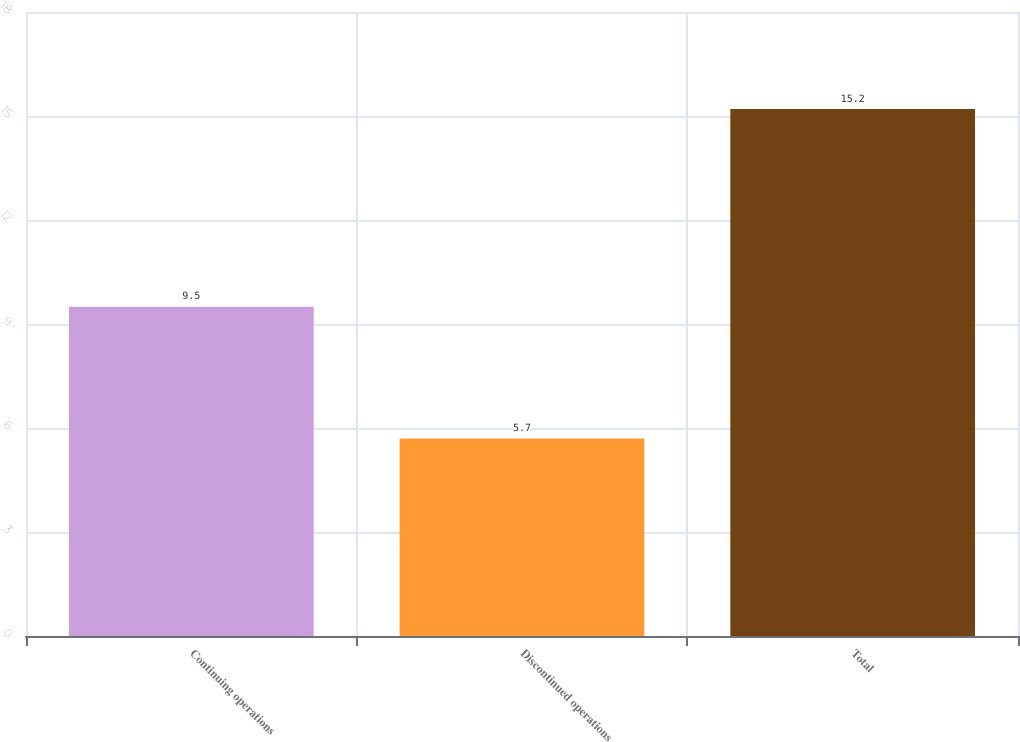Convert chart to OTSL. <chart><loc_0><loc_0><loc_500><loc_500><bar_chart><fcel>Continuing operations<fcel>Discontinued operations<fcel>Total<nl><fcel>9.5<fcel>5.7<fcel>15.2<nl></chart> 